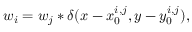<formula> <loc_0><loc_0><loc_500><loc_500>w _ { i } = w _ { j } \ast \delta ( x - x _ { 0 } ^ { i , j } , y - y _ { 0 } ^ { i , j } ) ,</formula> 